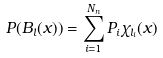<formula> <loc_0><loc_0><loc_500><loc_500>P ( B _ { l } ( x ) ) = \sum _ { i = 1 } ^ { N _ { n } } P _ { i } \chi _ { l _ { i } } ( x )</formula> 